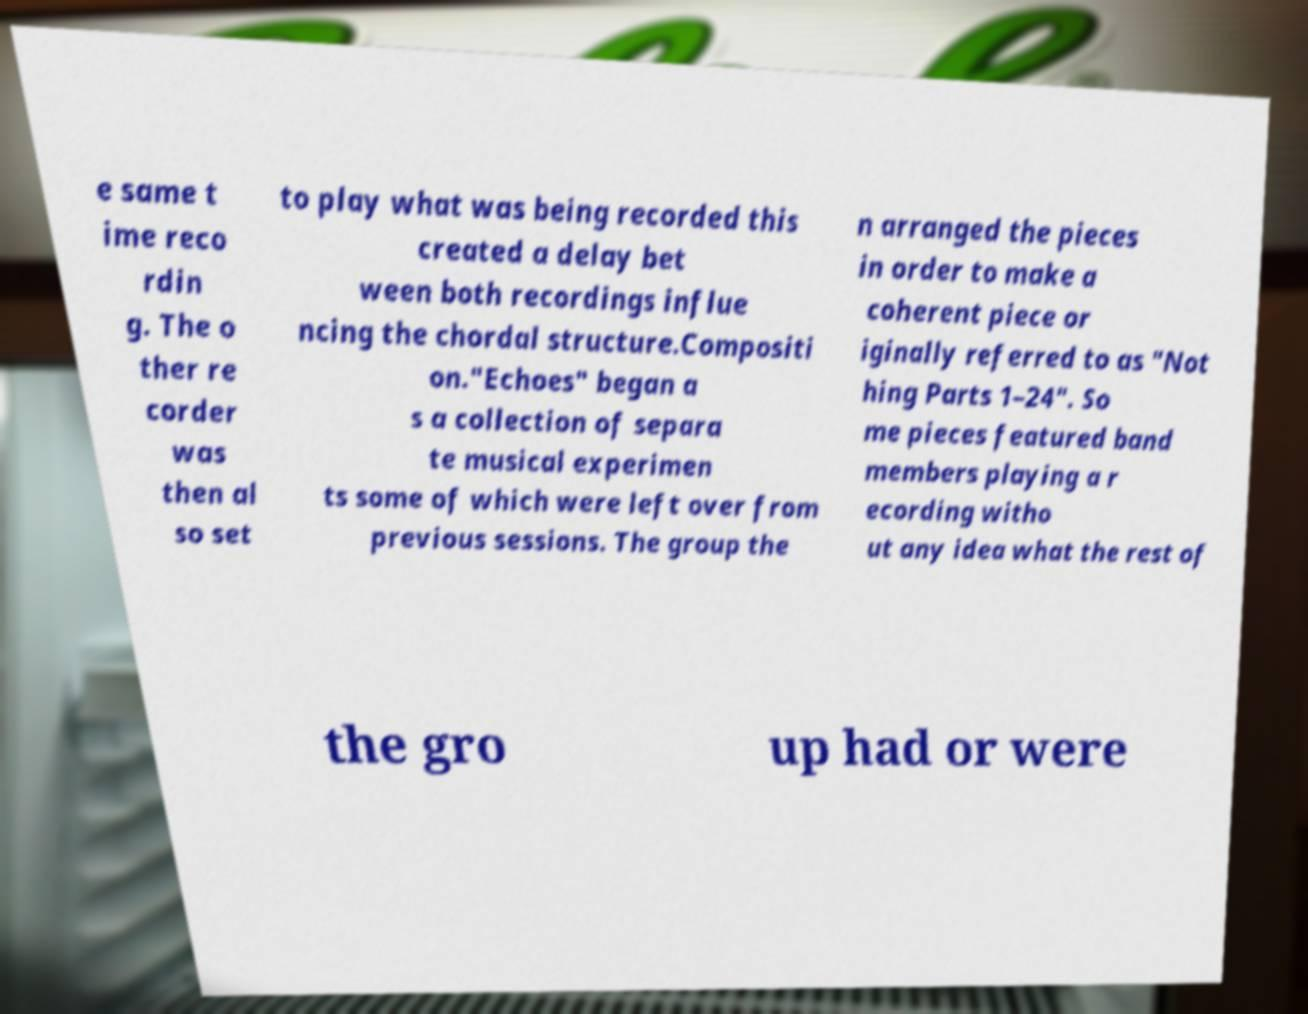Could you extract and type out the text from this image? e same t ime reco rdin g. The o ther re corder was then al so set to play what was being recorded this created a delay bet ween both recordings influe ncing the chordal structure.Compositi on."Echoes" began a s a collection of separa te musical experimen ts some of which were left over from previous sessions. The group the n arranged the pieces in order to make a coherent piece or iginally referred to as "Not hing Parts 1–24". So me pieces featured band members playing a r ecording witho ut any idea what the rest of the gro up had or were 